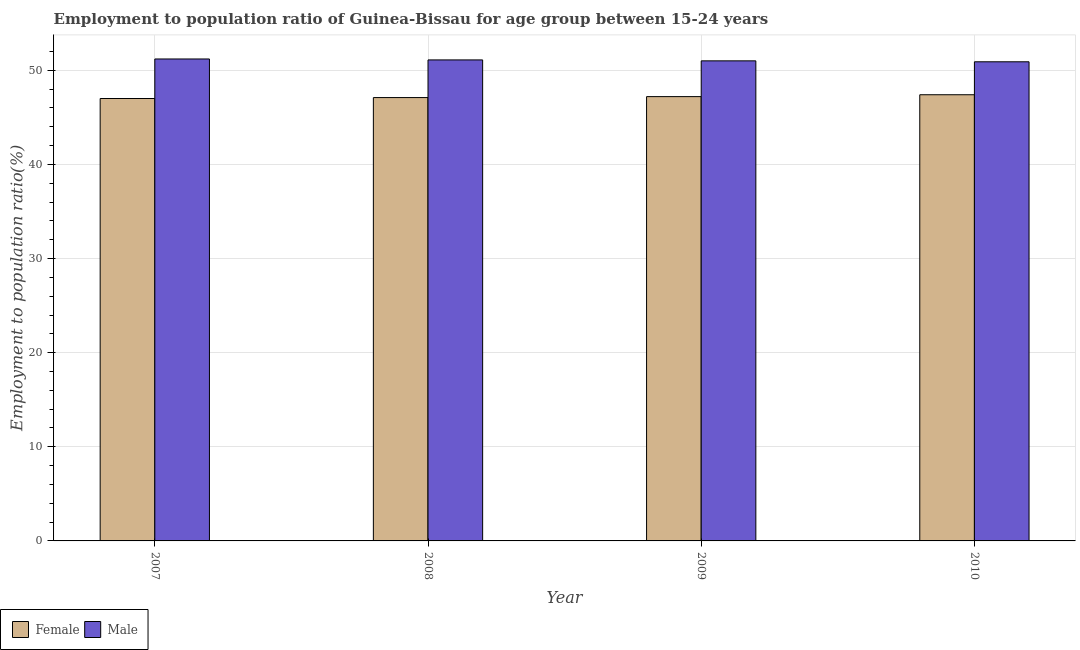How many different coloured bars are there?
Your answer should be compact. 2. How many groups of bars are there?
Make the answer very short. 4. What is the label of the 3rd group of bars from the left?
Give a very brief answer. 2009. In how many cases, is the number of bars for a given year not equal to the number of legend labels?
Keep it short and to the point. 0. Across all years, what is the maximum employment to population ratio(female)?
Your answer should be compact. 47.4. Across all years, what is the minimum employment to population ratio(male)?
Make the answer very short. 50.9. In which year was the employment to population ratio(female) minimum?
Offer a very short reply. 2007. What is the total employment to population ratio(male) in the graph?
Your answer should be compact. 204.2. What is the difference between the employment to population ratio(female) in 2007 and that in 2010?
Offer a terse response. -0.4. What is the difference between the employment to population ratio(male) in 2009 and the employment to population ratio(female) in 2010?
Make the answer very short. 0.1. What is the average employment to population ratio(male) per year?
Ensure brevity in your answer.  51.05. In how many years, is the employment to population ratio(male) greater than 24 %?
Offer a very short reply. 4. What is the ratio of the employment to population ratio(male) in 2008 to that in 2010?
Your answer should be very brief. 1. Is the difference between the employment to population ratio(male) in 2009 and 2010 greater than the difference between the employment to population ratio(female) in 2009 and 2010?
Provide a short and direct response. No. What is the difference between the highest and the second highest employment to population ratio(male)?
Keep it short and to the point. 0.1. What is the difference between the highest and the lowest employment to population ratio(male)?
Keep it short and to the point. 0.3. In how many years, is the employment to population ratio(female) greater than the average employment to population ratio(female) taken over all years?
Give a very brief answer. 2. How many bars are there?
Make the answer very short. 8. Are all the bars in the graph horizontal?
Offer a very short reply. No. What is the difference between two consecutive major ticks on the Y-axis?
Offer a very short reply. 10. Are the values on the major ticks of Y-axis written in scientific E-notation?
Offer a terse response. No. Does the graph contain any zero values?
Keep it short and to the point. No. Does the graph contain grids?
Provide a short and direct response. Yes. Where does the legend appear in the graph?
Make the answer very short. Bottom left. How many legend labels are there?
Offer a very short reply. 2. How are the legend labels stacked?
Your answer should be compact. Horizontal. What is the title of the graph?
Offer a terse response. Employment to population ratio of Guinea-Bissau for age group between 15-24 years. What is the label or title of the X-axis?
Your response must be concise. Year. What is the label or title of the Y-axis?
Your response must be concise. Employment to population ratio(%). What is the Employment to population ratio(%) of Male in 2007?
Your response must be concise. 51.2. What is the Employment to population ratio(%) in Female in 2008?
Provide a short and direct response. 47.1. What is the Employment to population ratio(%) in Male in 2008?
Make the answer very short. 51.1. What is the Employment to population ratio(%) in Female in 2009?
Ensure brevity in your answer.  47.2. What is the Employment to population ratio(%) of Female in 2010?
Give a very brief answer. 47.4. What is the Employment to population ratio(%) in Male in 2010?
Ensure brevity in your answer.  50.9. Across all years, what is the maximum Employment to population ratio(%) in Female?
Provide a short and direct response. 47.4. Across all years, what is the maximum Employment to population ratio(%) in Male?
Offer a very short reply. 51.2. Across all years, what is the minimum Employment to population ratio(%) in Female?
Your answer should be very brief. 47. Across all years, what is the minimum Employment to population ratio(%) of Male?
Give a very brief answer. 50.9. What is the total Employment to population ratio(%) in Female in the graph?
Your response must be concise. 188.7. What is the total Employment to population ratio(%) of Male in the graph?
Give a very brief answer. 204.2. What is the difference between the Employment to population ratio(%) in Female in 2008 and that in 2009?
Keep it short and to the point. -0.1. What is the difference between the Employment to population ratio(%) in Female in 2008 and that in 2010?
Make the answer very short. -0.3. What is the difference between the Employment to population ratio(%) in Female in 2009 and that in 2010?
Make the answer very short. -0.2. What is the difference between the Employment to population ratio(%) of Male in 2009 and that in 2010?
Offer a very short reply. 0.1. What is the difference between the Employment to population ratio(%) in Female in 2007 and the Employment to population ratio(%) in Male in 2008?
Provide a short and direct response. -4.1. What is the difference between the Employment to population ratio(%) in Female in 2007 and the Employment to population ratio(%) in Male in 2009?
Your answer should be very brief. -4. What is the difference between the Employment to population ratio(%) in Female in 2007 and the Employment to population ratio(%) in Male in 2010?
Your answer should be very brief. -3.9. What is the difference between the Employment to population ratio(%) in Female in 2008 and the Employment to population ratio(%) in Male in 2009?
Keep it short and to the point. -3.9. What is the difference between the Employment to population ratio(%) in Female in 2008 and the Employment to population ratio(%) in Male in 2010?
Make the answer very short. -3.8. What is the difference between the Employment to population ratio(%) of Female in 2009 and the Employment to population ratio(%) of Male in 2010?
Provide a short and direct response. -3.7. What is the average Employment to population ratio(%) in Female per year?
Offer a terse response. 47.17. What is the average Employment to population ratio(%) of Male per year?
Your response must be concise. 51.05. In the year 2007, what is the difference between the Employment to population ratio(%) in Female and Employment to population ratio(%) in Male?
Make the answer very short. -4.2. In the year 2008, what is the difference between the Employment to population ratio(%) in Female and Employment to population ratio(%) in Male?
Offer a terse response. -4. In the year 2009, what is the difference between the Employment to population ratio(%) in Female and Employment to population ratio(%) in Male?
Offer a very short reply. -3.8. In the year 2010, what is the difference between the Employment to population ratio(%) of Female and Employment to population ratio(%) of Male?
Your answer should be compact. -3.5. What is the ratio of the Employment to population ratio(%) in Female in 2007 to that in 2008?
Keep it short and to the point. 1. What is the ratio of the Employment to population ratio(%) in Male in 2007 to that in 2008?
Provide a short and direct response. 1. What is the ratio of the Employment to population ratio(%) of Male in 2007 to that in 2010?
Offer a terse response. 1.01. What is the ratio of the Employment to population ratio(%) of Female in 2008 to that in 2009?
Ensure brevity in your answer.  1. What is the ratio of the Employment to population ratio(%) in Male in 2008 to that in 2009?
Your answer should be compact. 1. What is the ratio of the Employment to population ratio(%) of Male in 2008 to that in 2010?
Keep it short and to the point. 1. What is the ratio of the Employment to population ratio(%) of Female in 2009 to that in 2010?
Ensure brevity in your answer.  1. What is the ratio of the Employment to population ratio(%) in Male in 2009 to that in 2010?
Your answer should be compact. 1. What is the difference between the highest and the lowest Employment to population ratio(%) in Female?
Offer a very short reply. 0.4. 